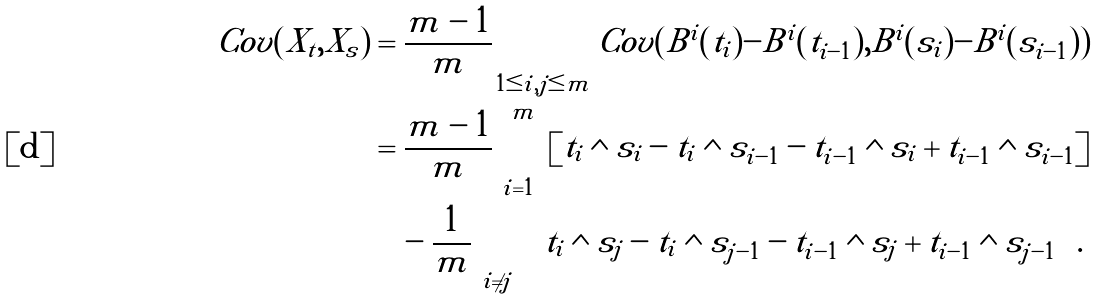Convert formula to latex. <formula><loc_0><loc_0><loc_500><loc_500>C o v ( X _ { t } , X _ { s } ) & = \frac { m - 1 } { m } \sum _ { 1 \leq i , j \leq m } C o v ( \tilde { B } ^ { i } ( t _ { i } ) - \tilde { B } ^ { i } ( t _ { i - 1 } ) , \tilde { B } ^ { i } ( s _ { i } ) - \tilde { B } ^ { i } ( s _ { i - 1 } ) ) \\ & = \frac { m - 1 } { m } \sum ^ { m } _ { i = 1 } \left [ t _ { i } \wedge s _ { i } - t _ { i } \wedge s _ { i - 1 } - t _ { i - 1 } \wedge s _ { i } + t _ { i - 1 } \wedge s _ { i - 1 } \right ] \\ & \quad - \frac { 1 } { m } \sum _ { i \ne j } \left [ t _ { i } \wedge s _ { j } - t _ { i } \wedge s _ { j - 1 } - t _ { i - 1 } \wedge s _ { j } + t _ { i - 1 } \wedge s _ { j - 1 } \right ] .</formula> 